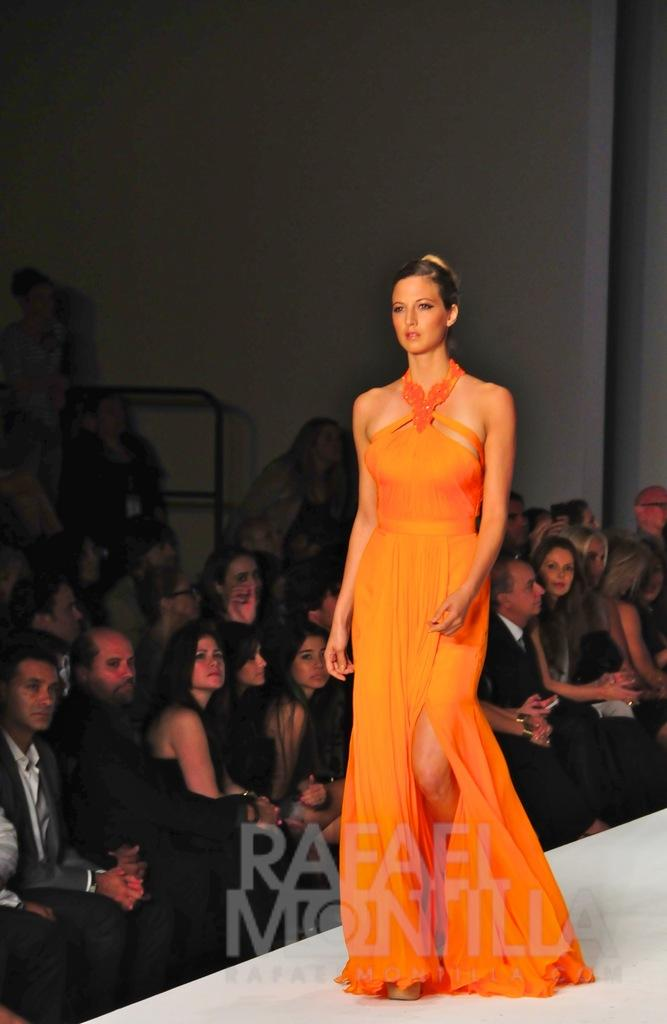How many people are in the image? There are people in the image, but the exact number is not specified. What is one person doing in the image? One person is walking on a stage in the image. What can be seen behind the people in the image? There is a wall visible in the background of the image. What type of hand is holding the microphone in the image? There is no mention of a microphone or a hand holding it in the image, so this question cannot be answered. 